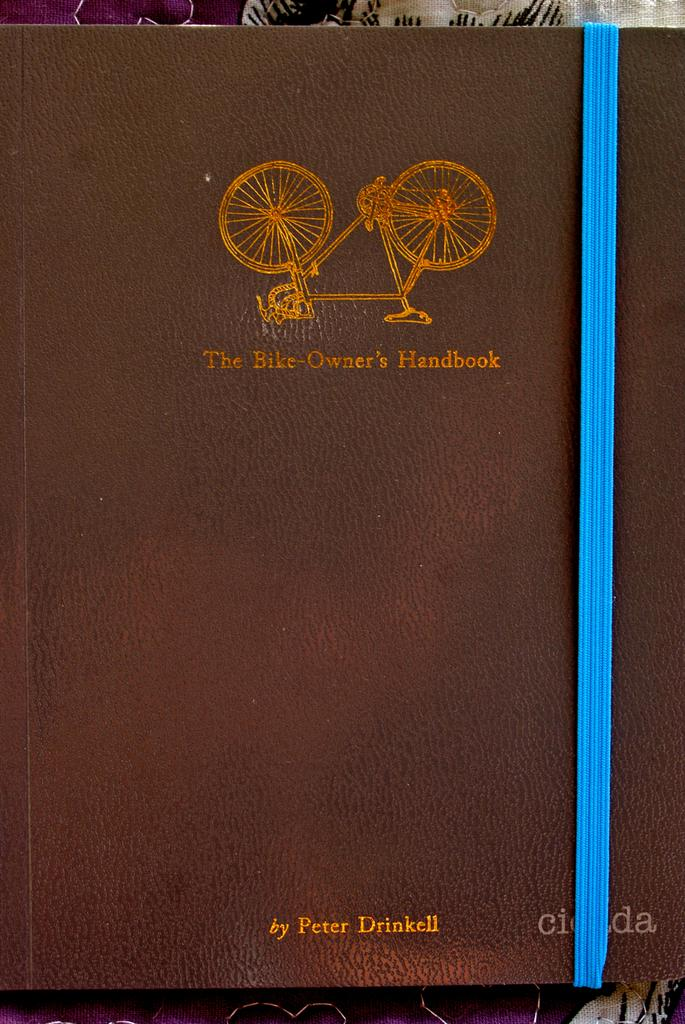<image>
Relay a brief, clear account of the picture shown. A leatherbound book "The Bike Owner's Handbook" by Peter Drinkell has a blue band around it. 